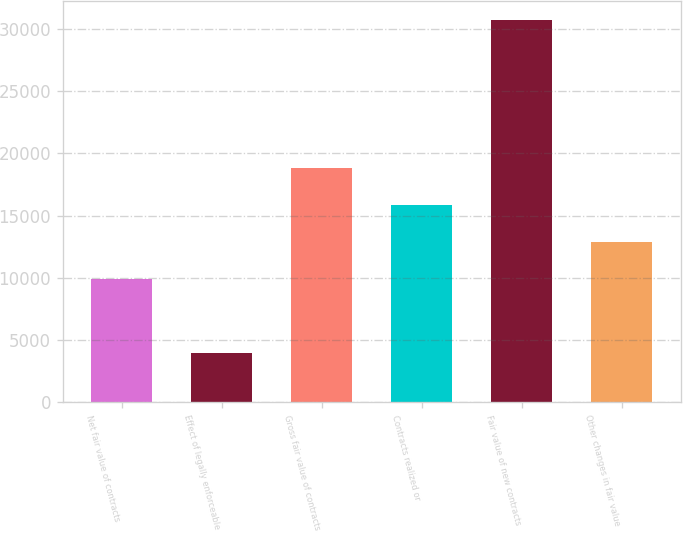Convert chart. <chart><loc_0><loc_0><loc_500><loc_500><bar_chart><fcel>Net fair value of contracts<fcel>Effect of legally enforceable<fcel>Gross fair value of contracts<fcel>Contracts realized or<fcel>Fair value of new contracts<fcel>Other changes in fair value<nl><fcel>9906.6<fcel>3968.2<fcel>18814.2<fcel>15845<fcel>30691<fcel>12875.8<nl></chart> 